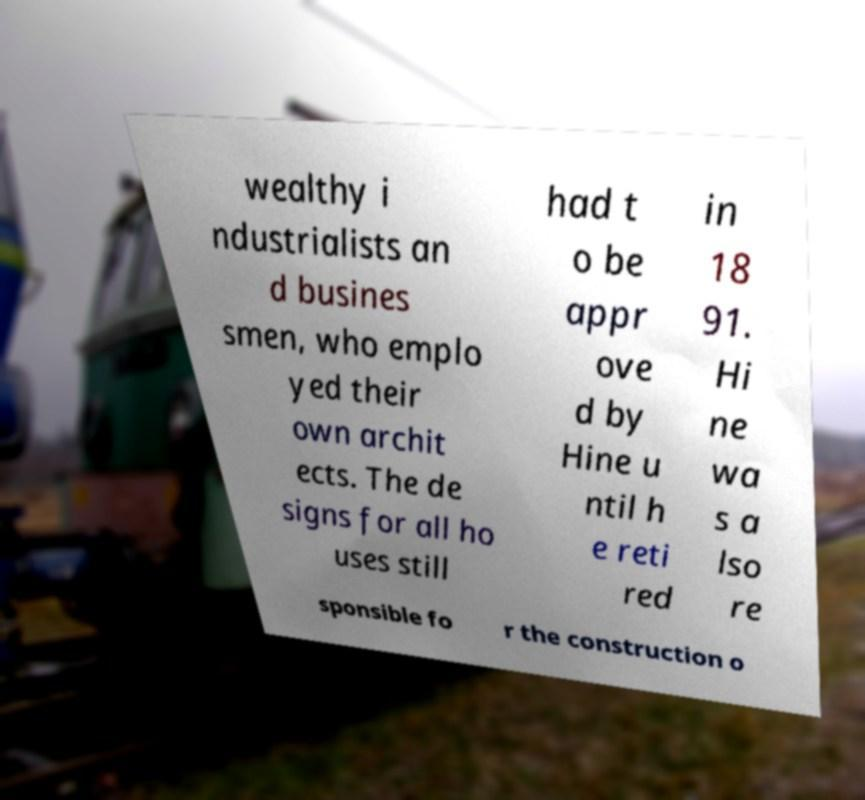Could you assist in decoding the text presented in this image and type it out clearly? wealthy i ndustrialists an d busines smen, who emplo yed their own archit ects. The de signs for all ho uses still had t o be appr ove d by Hine u ntil h e reti red in 18 91. Hi ne wa s a lso re sponsible fo r the construction o 